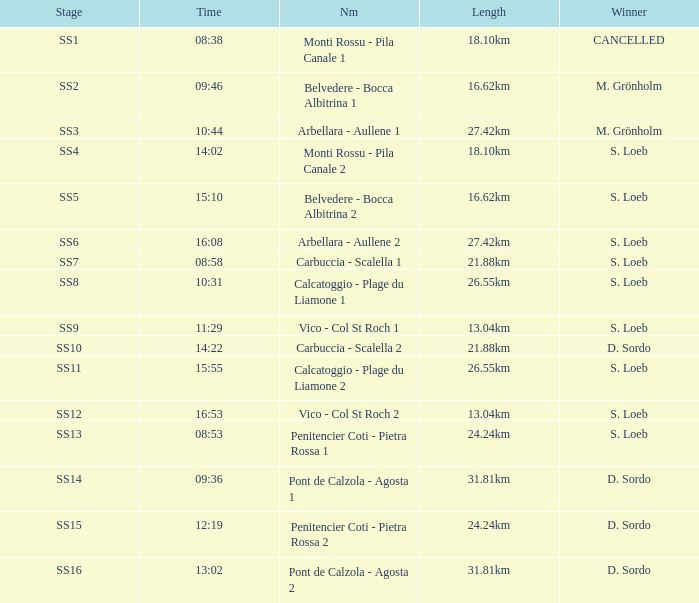What is the Name of the stage with S. Loeb as the Winner with a Length of 13.04km and a Stage of SS12? Vico - Col St Roch 2. 